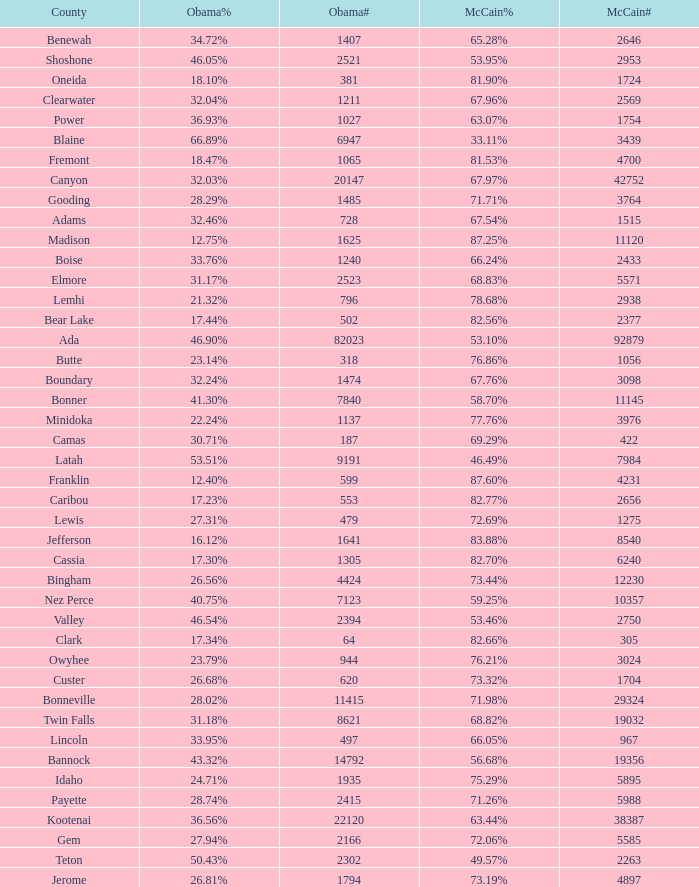What is the maximum McCain population turnout number? 92879.0. 